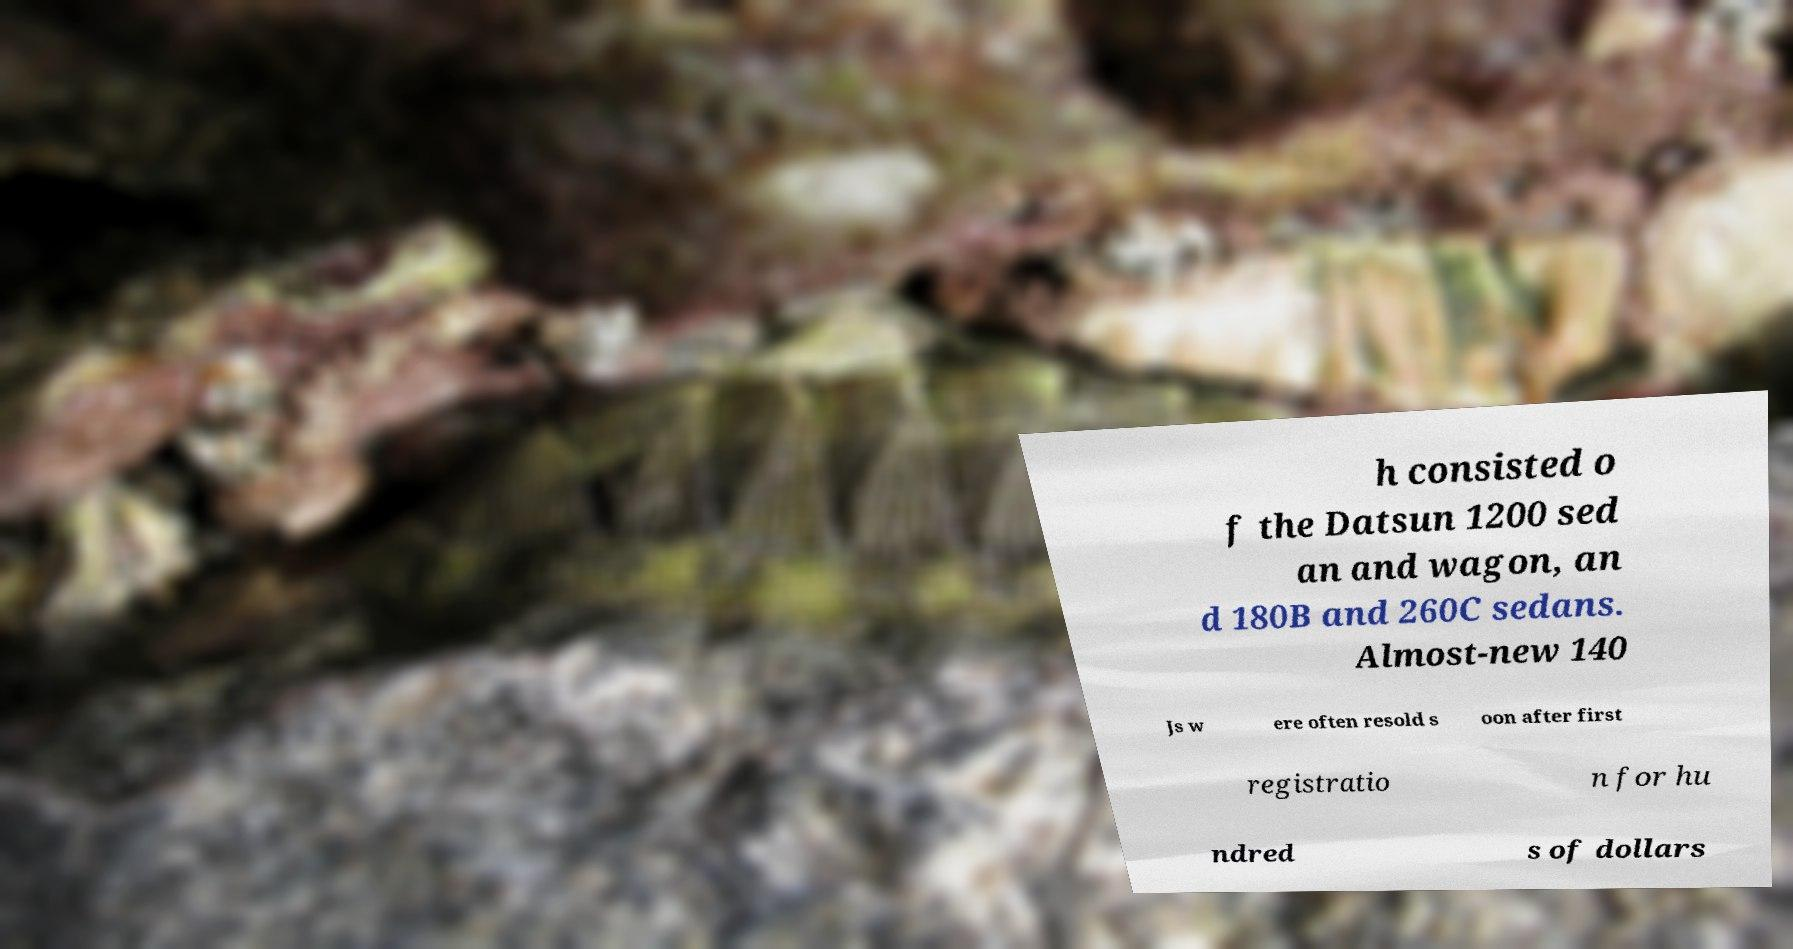Could you assist in decoding the text presented in this image and type it out clearly? h consisted o f the Datsun 1200 sed an and wagon, an d 180B and 260C sedans. Almost-new 140 Js w ere often resold s oon after first registratio n for hu ndred s of dollars 